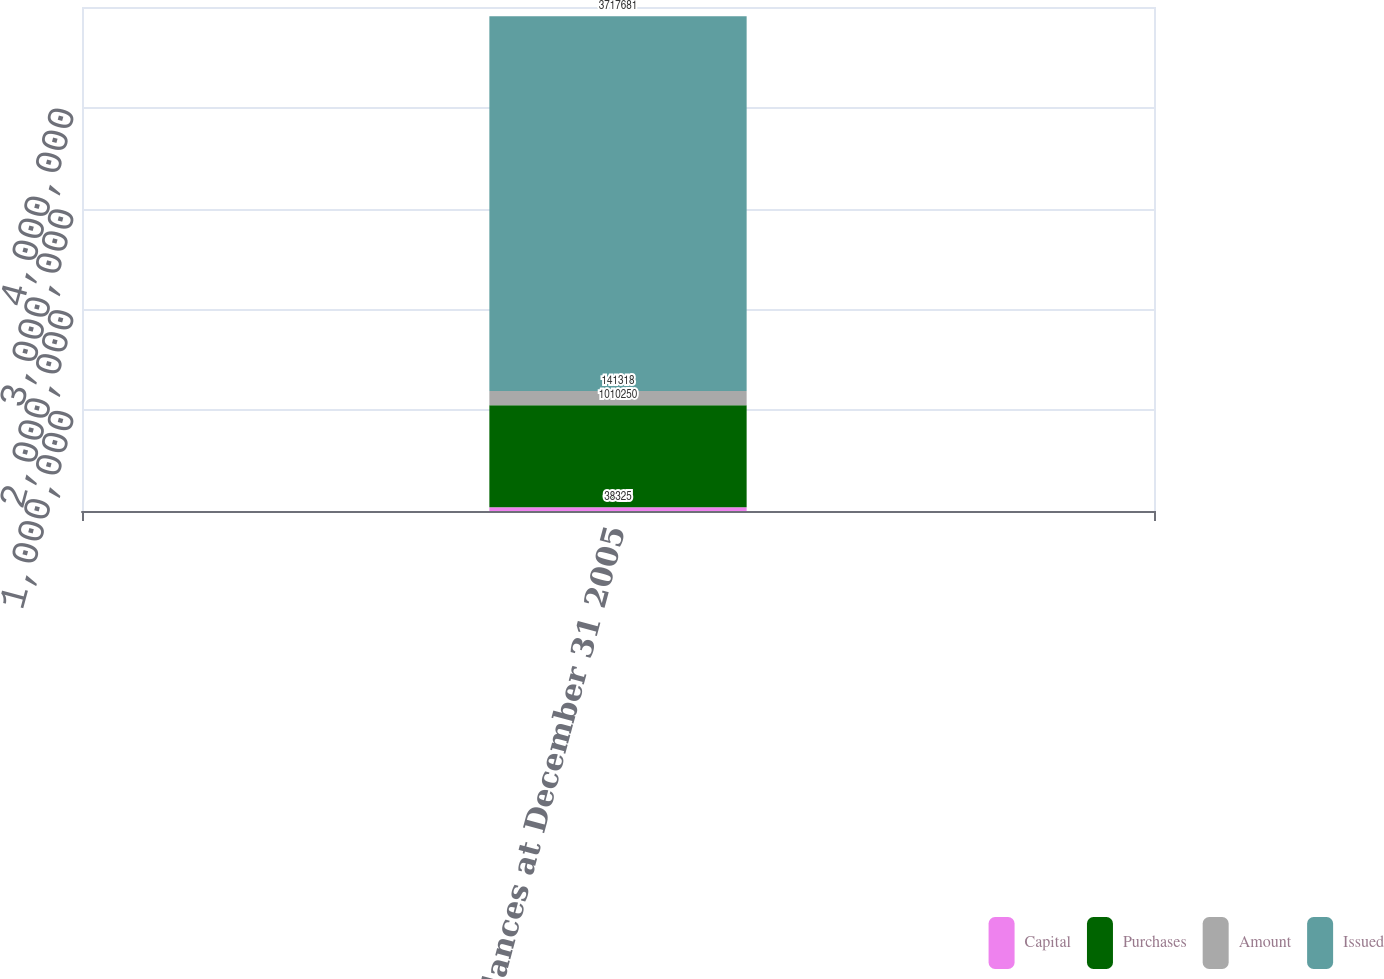Convert chart to OTSL. <chart><loc_0><loc_0><loc_500><loc_500><stacked_bar_chart><ecel><fcel>Balances at December 31 2005<nl><fcel>Capital<fcel>38325<nl><fcel>Purchases<fcel>1.01025e+06<nl><fcel>Amount<fcel>141318<nl><fcel>Issued<fcel>3.71768e+06<nl></chart> 